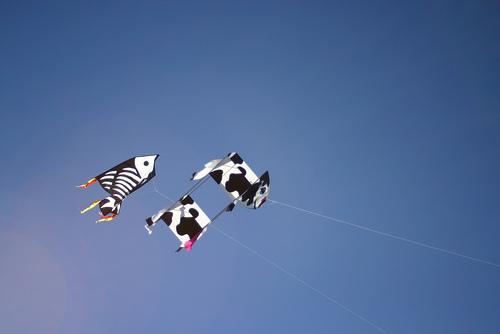What animal pattern is the two piece kite using? cow 